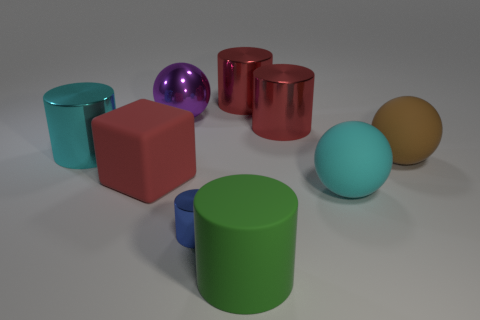Are there any other things that are the same size as the blue cylinder?
Offer a very short reply. No. How many other objects are the same color as the matte block?
Offer a very short reply. 2. Is the number of blue things that are left of the cyan metallic cylinder less than the number of red objects to the right of the green rubber object?
Make the answer very short. Yes. What number of big blue rubber objects are there?
Provide a succinct answer. 0. Is there any other thing that has the same material as the purple ball?
Your answer should be compact. Yes. What material is the green object that is the same shape as the blue shiny thing?
Keep it short and to the point. Rubber. Is the number of purple spheres right of the matte cylinder less than the number of tiny yellow cubes?
Offer a very short reply. No. There is a cyan thing on the right side of the red block; does it have the same shape as the green object?
Provide a succinct answer. No. Is there any other thing of the same color as the block?
Provide a succinct answer. Yes. What size is the blue cylinder that is the same material as the big cyan cylinder?
Your answer should be compact. Small. 